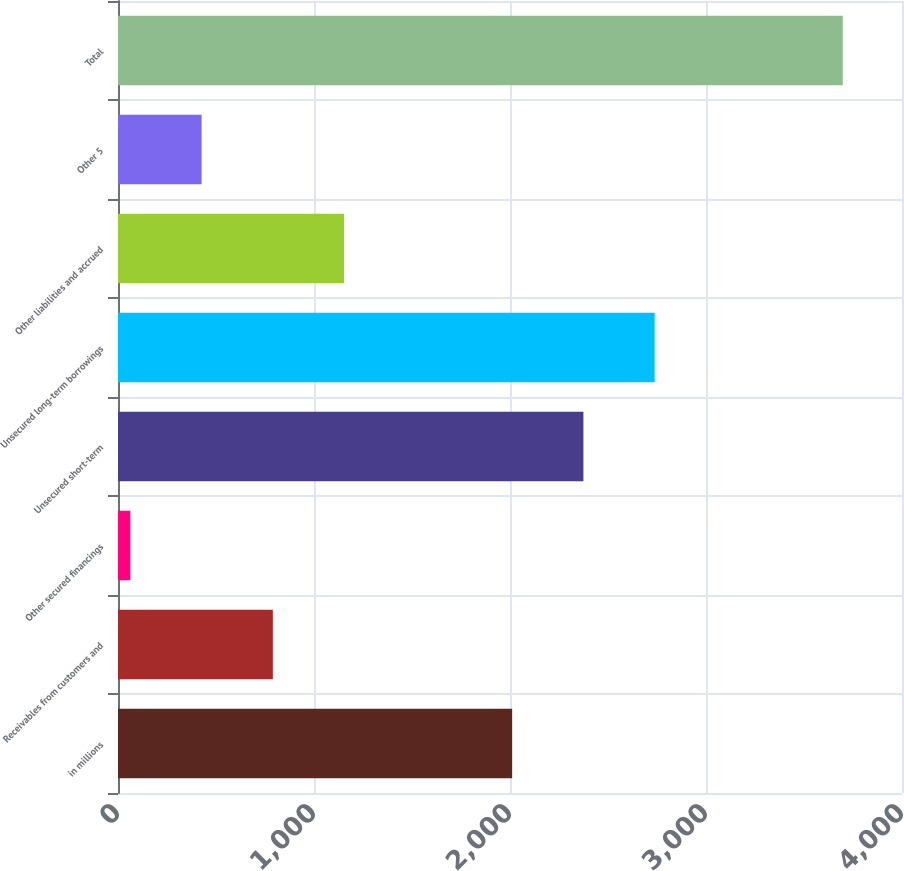Convert chart to OTSL. <chart><loc_0><loc_0><loc_500><loc_500><bar_chart><fcel>in millions<fcel>Receivables from customers and<fcel>Other secured financings<fcel>Unsecured short-term<fcel>Unsecured long-term borrowings<fcel>Other liabilities and accrued<fcel>Other 5<fcel>Total<nl><fcel>2011<fcel>790<fcel>63<fcel>2374.5<fcel>2738<fcel>1153.5<fcel>426.5<fcel>3698<nl></chart> 